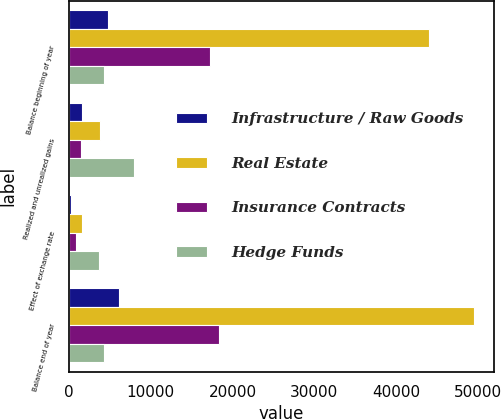Convert chart to OTSL. <chart><loc_0><loc_0><loc_500><loc_500><stacked_bar_chart><ecel><fcel>Balance beginning of year<fcel>Realized and unrealized gains<fcel>Effect of exchange rate<fcel>Balance end of year<nl><fcel>Infrastructure / Raw Goods<fcel>4776<fcel>1572<fcel>237<fcel>6111<nl><fcel>Real Estate<fcel>43997<fcel>3836<fcel>1598<fcel>49537<nl><fcel>Insurance Contracts<fcel>17293<fcel>1422<fcel>813<fcel>18291<nl><fcel>Hedge Funds<fcel>4306<fcel>7975<fcel>3649<fcel>4306<nl></chart> 